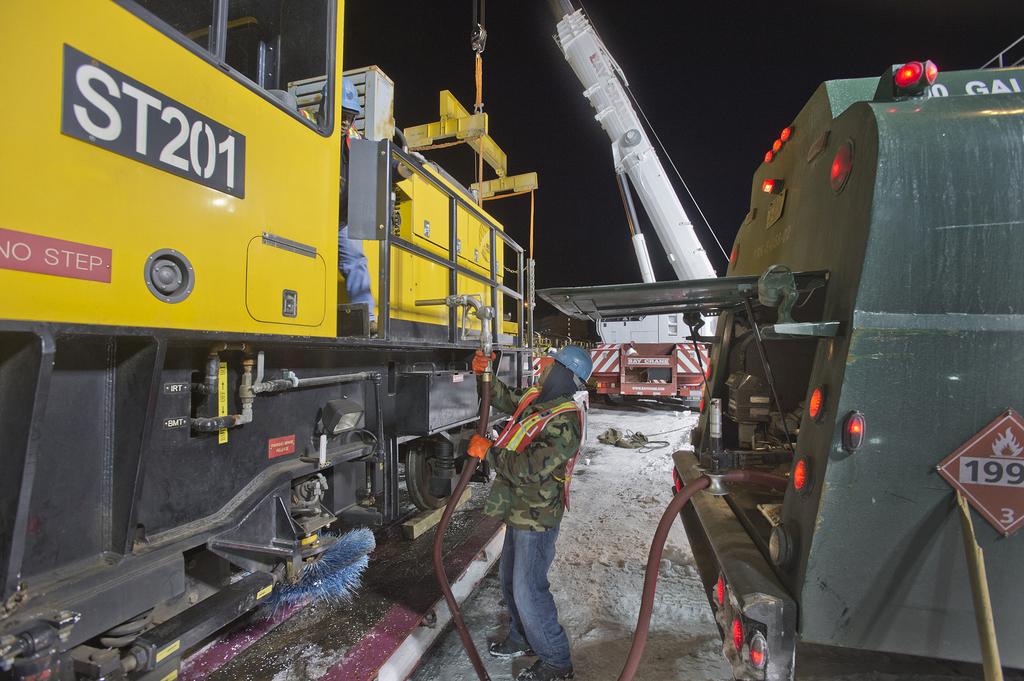What three numbers follow the letters "st"?
Offer a terse response. 201. What can't you do according to the sign?
Provide a short and direct response. Step. 